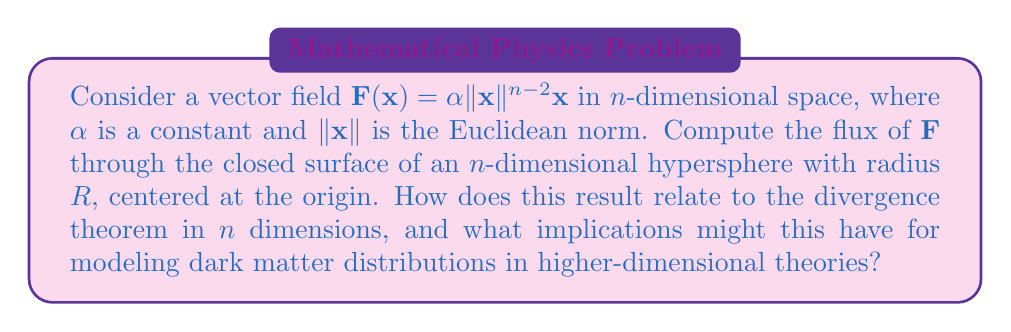What is the answer to this math problem? 1) First, we need to recall the generalized divergence theorem in $n$ dimensions:

   $$\int_V \nabla \cdot \mathbf{F} \, dV = \oint_S \mathbf{F} \cdot \mathbf{n} \, dS$$

   where $V$ is the volume enclosed by the surface $S$, and $\mathbf{n}$ is the outward unit normal vector.

2) Calculate the divergence of $\mathbf{F}$:
   $$\nabla \cdot \mathbf{F} = \nabla \cdot (\alpha\|\mathbf{x}\|^{n-2}\mathbf{x}) = \alpha(n-2)\|\mathbf{x}\|^{n-2} + \alpha n\|\mathbf{x}\|^{n-2} = \alpha(2n-2)\|\mathbf{x}\|^{n-2}$$

3) The volume of an $n$-dimensional ball of radius $R$ is:
   $$V_n(R) = \frac{\pi^{n/2}}{\Gamma(n/2+1)}R^n$$

   where $\Gamma$ is the gamma function.

4) Apply the divergence theorem:
   $$\begin{align*}
   \text{Flux} &= \oint_S \mathbf{F} \cdot \mathbf{n} \, dS = \int_V \nabla \cdot \mathbf{F} \, dV \\
   &= \int_V \alpha(2n-2)\|\mathbf{x}\|^{n-2} \, dV \\
   &= \alpha(2n-2) \int_0^R r^{n-2} \cdot \frac{n\pi^{n/2}}{\Gamma(n/2+1)}r^{n-1} \, dr \\
   &= \alpha(2n-2) \frac{n\pi^{n/2}}{\Gamma(n/2+1)} \int_0^R r^{2n-3} \, dr \\
   &= \alpha(2n-2) \frac{n\pi^{n/2}}{\Gamma(n/2+1)} \cdot \frac{R^{2n-2}}{2n-2} \\
   &= \alpha n \frac{\pi^{n/2}}{\Gamma(n/2+1)} R^{2n-2}
   \end{align*}$$

5) This result confirms the divergence theorem in $n$ dimensions, as it equals the surface integral of $\mathbf{F} \cdot \mathbf{n}$ over the hypersphere.

6) For dark matter modeling, this result suggests that in higher-dimensional theories, the flux through hypersurfaces could scale differently with radius, potentially explaining anomalous gravitational effects attributed to dark matter.
Answer: $\alpha n \frac{\pi^{n/2}}{\Gamma(n/2+1)} R^{2n-2}$ 